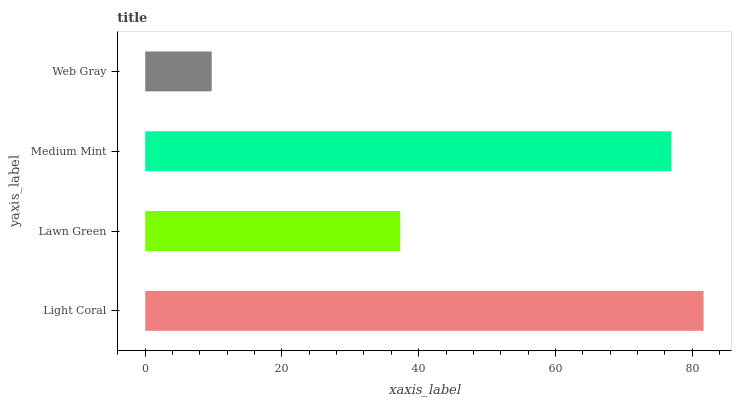Is Web Gray the minimum?
Answer yes or no. Yes. Is Light Coral the maximum?
Answer yes or no. Yes. Is Lawn Green the minimum?
Answer yes or no. No. Is Lawn Green the maximum?
Answer yes or no. No. Is Light Coral greater than Lawn Green?
Answer yes or no. Yes. Is Lawn Green less than Light Coral?
Answer yes or no. Yes. Is Lawn Green greater than Light Coral?
Answer yes or no. No. Is Light Coral less than Lawn Green?
Answer yes or no. No. Is Medium Mint the high median?
Answer yes or no. Yes. Is Lawn Green the low median?
Answer yes or no. Yes. Is Light Coral the high median?
Answer yes or no. No. Is Light Coral the low median?
Answer yes or no. No. 